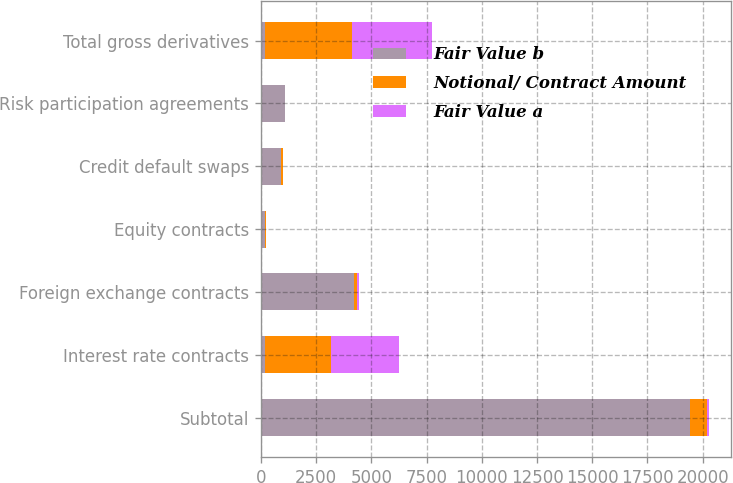Convert chart. <chart><loc_0><loc_0><loc_500><loc_500><stacked_bar_chart><ecel><fcel>Subtotal<fcel>Interest rate contracts<fcel>Foreign exchange contracts<fcel>Equity contracts<fcel>Credit default swaps<fcel>Risk participation agreements<fcel>Total gross derivatives<nl><fcel>Fair Value b<fcel>19442<fcel>195<fcel>4208<fcel>195<fcel>926<fcel>1091<fcel>195<nl><fcel>Notional/ Contract Amount<fcel>739<fcel>2963<fcel>123<fcel>16<fcel>72<fcel>3<fcel>3916<nl><fcel>Fair Value a<fcel>95<fcel>3110<fcel>108<fcel>16<fcel>22<fcel>2<fcel>3628<nl></chart> 